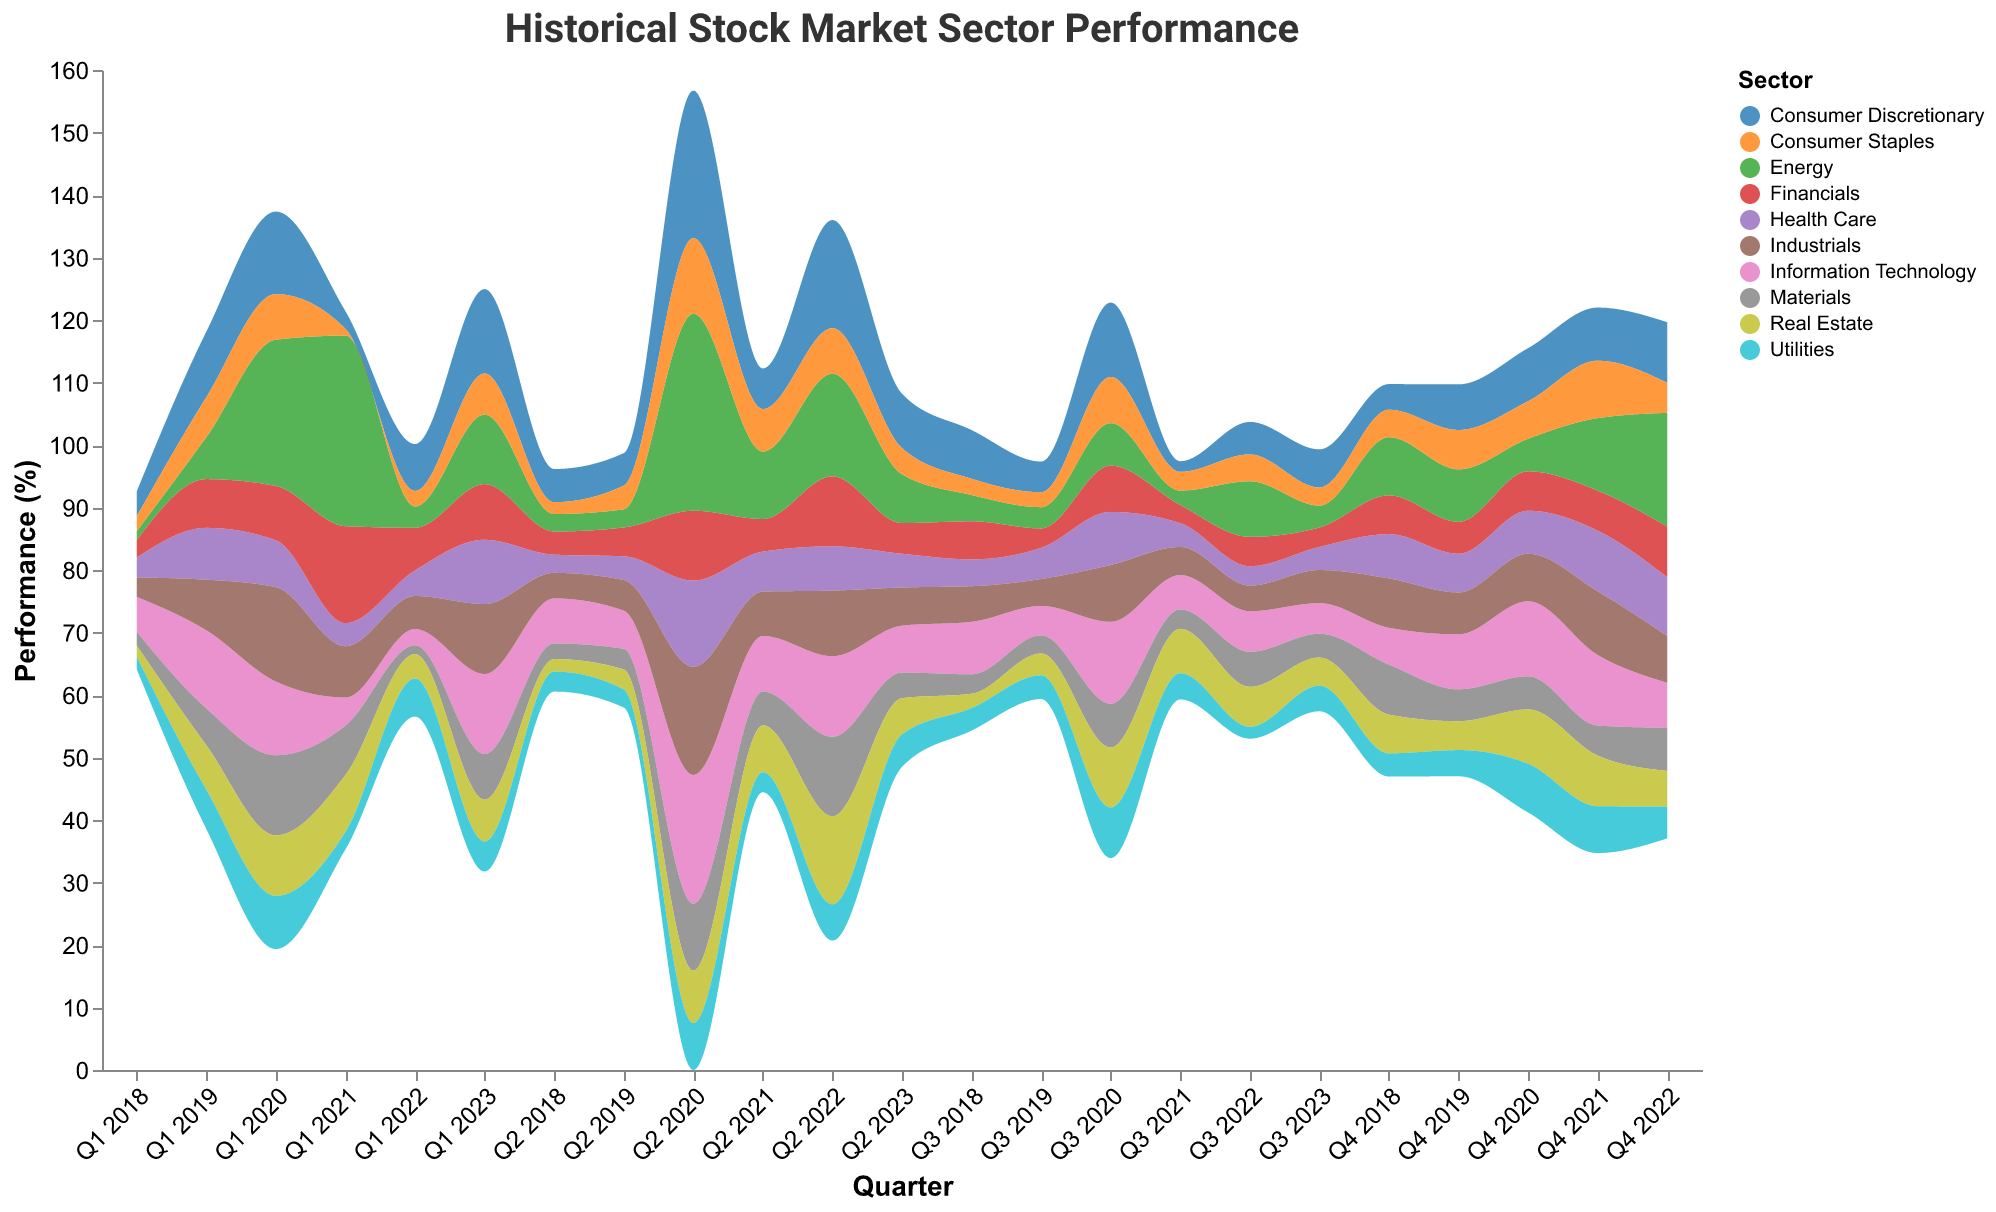What's the title of the figure? The title of the figure is displayed at the top of the visualization and reads "Historical Stock Market Sector Performance".
Answer: Historical Stock Market Sector Performance What sectors showed a negative performance in Q4 2018? In Q4 2018, the negative performance sectors are those with values below zero, visible in the downward areas of the stream graph. These sectors are Information Technology, Health Care, Financials, Consumer Discretionary, Industrials, Energy, Materials, Real Estate, Utilities, and Consumer Staples.
Answer: Information Technology, Health Care, Financials, Consumer Discretionary, Industrials, Energy, Materials, Real Estate, Utilities, Consumer Staples Which sector had the highest performance in Q2 2020? To answer this, look for the sector with the widest stream in Q2 2020. Energy has the highest percentage performance.
Answer: Energy During which quarter did Information Technology achieve the largest positive growth? By observing the peaks of the Information Technology section in different quarters, you see that Q2 2020 shows the highest positive growth at 20.6%.
Answer: Q2 2020 How did the Energy sector perform in Q1 2021 compared to Q1 2020? To compare, note that Energy's performance in Q1 2021 was 30.5%, whereas in Q1 2020, it was -23.4%. The difference is calculated as 30.5 - (-23.4) = 53.9. The reversal from negative to a strong positive shows a significant improvement.
Answer: 53.9 What was the average performance of Consumer Discretionary over the year 2020? To find the average, sum up the quarterly performances for Consumer Discretionary in 2020 and divide by 4. The values are -13.2, 23.6, 11.9, and 8.5. Sum = 30.8, Average 30.8 / 4 = 7.7.
Answer: 7.7 Which sector had the most volatile performance between Q1 2020 and Q2 2020? Volatility is inferred by the change between two adjacent quarters. Energy moves from -23.4% in Q1 2020 to 31.5% in Q2 2020, a shift of 54.9 percentage points, indicating the highest volatility.
Answer: Energy What trend can be observed for Real Estate from Q2 2022 to Q3 2023? To observe the trend, follow the stream of the Real Estate sector from Q2 2022 (-14.1%) to Q3 2023 (4.5%). It shows an upward trend where the percentage increases each quarter but fluctuates within given periods.
Answer: Upward trend During which quarters did the Industrials sector show negative performance in 2022? To find the negative performance quarters for Industrials, locate the positions where its value is below zero in 2022. These are Q1 2022 and Q2 2022 (-5.3% and -10.5%).
Answer: Q1 2022, Q2 2022 What is the total performance of Health Care in the first and last quarters of the dataset? Calculate the sum of Health Care's performance for Q1 2018 and Q3 2023. Add the values 3.2 (Q1 2018) and 3.7 (Q3 2023). Therefore, the total performance is 3.2 + 3.7 = 6.9.
Answer: 6.9 